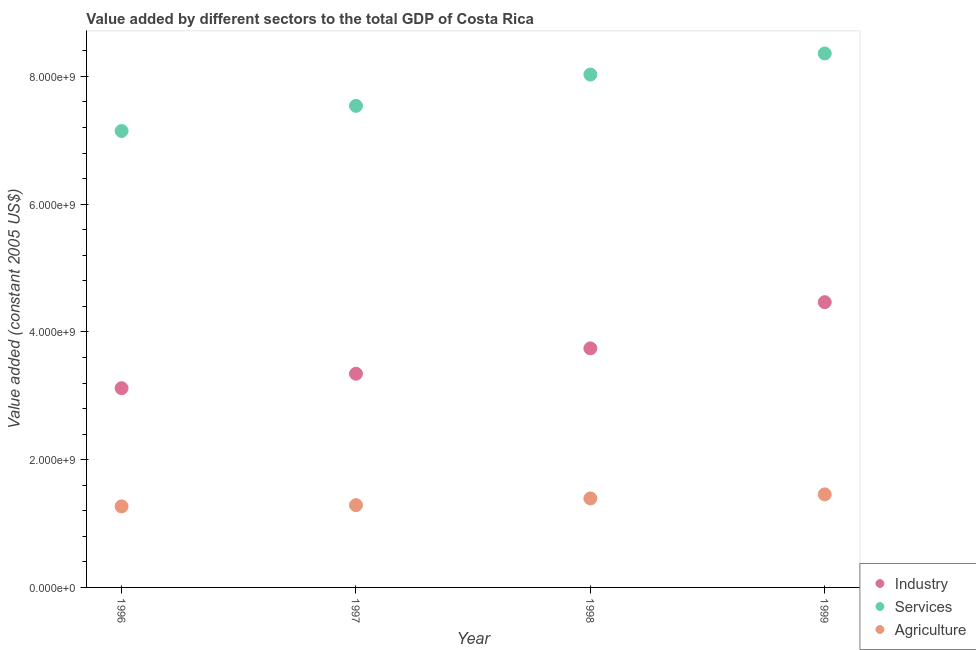Is the number of dotlines equal to the number of legend labels?
Your answer should be compact. Yes. What is the value added by industrial sector in 1997?
Your response must be concise. 3.35e+09. Across all years, what is the maximum value added by industrial sector?
Give a very brief answer. 4.47e+09. Across all years, what is the minimum value added by industrial sector?
Give a very brief answer. 3.12e+09. What is the total value added by agricultural sector in the graph?
Your answer should be very brief. 5.41e+09. What is the difference between the value added by agricultural sector in 1997 and that in 1999?
Offer a terse response. -1.69e+08. What is the difference between the value added by services in 1999 and the value added by agricultural sector in 1996?
Ensure brevity in your answer.  7.09e+09. What is the average value added by industrial sector per year?
Make the answer very short. 3.67e+09. In the year 1998, what is the difference between the value added by agricultural sector and value added by services?
Keep it short and to the point. -6.64e+09. In how many years, is the value added by agricultural sector greater than 6800000000 US$?
Give a very brief answer. 0. What is the ratio of the value added by agricultural sector in 1998 to that in 1999?
Provide a short and direct response. 0.96. Is the value added by industrial sector in 1997 less than that in 1999?
Offer a terse response. Yes. Is the difference between the value added by industrial sector in 1997 and 1999 greater than the difference between the value added by services in 1997 and 1999?
Keep it short and to the point. No. What is the difference between the highest and the second highest value added by services?
Provide a short and direct response. 3.30e+08. What is the difference between the highest and the lowest value added by industrial sector?
Give a very brief answer. 1.35e+09. In how many years, is the value added by industrial sector greater than the average value added by industrial sector taken over all years?
Your response must be concise. 2. Is it the case that in every year, the sum of the value added by industrial sector and value added by services is greater than the value added by agricultural sector?
Give a very brief answer. Yes. Is the value added by agricultural sector strictly greater than the value added by industrial sector over the years?
Keep it short and to the point. No. Is the value added by agricultural sector strictly less than the value added by industrial sector over the years?
Your response must be concise. Yes. How many dotlines are there?
Your answer should be very brief. 3. How many years are there in the graph?
Keep it short and to the point. 4. How many legend labels are there?
Keep it short and to the point. 3. How are the legend labels stacked?
Make the answer very short. Vertical. What is the title of the graph?
Your answer should be very brief. Value added by different sectors to the total GDP of Costa Rica. What is the label or title of the X-axis?
Your response must be concise. Year. What is the label or title of the Y-axis?
Give a very brief answer. Value added (constant 2005 US$). What is the Value added (constant 2005 US$) of Industry in 1996?
Make the answer very short. 3.12e+09. What is the Value added (constant 2005 US$) of Services in 1996?
Keep it short and to the point. 7.15e+09. What is the Value added (constant 2005 US$) in Agriculture in 1996?
Your response must be concise. 1.27e+09. What is the Value added (constant 2005 US$) in Industry in 1997?
Ensure brevity in your answer.  3.35e+09. What is the Value added (constant 2005 US$) of Services in 1997?
Provide a short and direct response. 7.54e+09. What is the Value added (constant 2005 US$) in Agriculture in 1997?
Your response must be concise. 1.29e+09. What is the Value added (constant 2005 US$) of Industry in 1998?
Ensure brevity in your answer.  3.74e+09. What is the Value added (constant 2005 US$) in Services in 1998?
Offer a very short reply. 8.03e+09. What is the Value added (constant 2005 US$) of Agriculture in 1998?
Provide a succinct answer. 1.39e+09. What is the Value added (constant 2005 US$) in Industry in 1999?
Your answer should be compact. 4.47e+09. What is the Value added (constant 2005 US$) of Services in 1999?
Ensure brevity in your answer.  8.36e+09. What is the Value added (constant 2005 US$) of Agriculture in 1999?
Make the answer very short. 1.46e+09. Across all years, what is the maximum Value added (constant 2005 US$) in Industry?
Make the answer very short. 4.47e+09. Across all years, what is the maximum Value added (constant 2005 US$) of Services?
Ensure brevity in your answer.  8.36e+09. Across all years, what is the maximum Value added (constant 2005 US$) in Agriculture?
Make the answer very short. 1.46e+09. Across all years, what is the minimum Value added (constant 2005 US$) in Industry?
Your answer should be very brief. 3.12e+09. Across all years, what is the minimum Value added (constant 2005 US$) of Services?
Your response must be concise. 7.15e+09. Across all years, what is the minimum Value added (constant 2005 US$) in Agriculture?
Give a very brief answer. 1.27e+09. What is the total Value added (constant 2005 US$) of Industry in the graph?
Your answer should be compact. 1.47e+1. What is the total Value added (constant 2005 US$) in Services in the graph?
Offer a very short reply. 3.11e+1. What is the total Value added (constant 2005 US$) in Agriculture in the graph?
Make the answer very short. 5.41e+09. What is the difference between the Value added (constant 2005 US$) of Industry in 1996 and that in 1997?
Offer a very short reply. -2.27e+08. What is the difference between the Value added (constant 2005 US$) in Services in 1996 and that in 1997?
Give a very brief answer. -3.93e+08. What is the difference between the Value added (constant 2005 US$) in Agriculture in 1996 and that in 1997?
Make the answer very short. -1.88e+07. What is the difference between the Value added (constant 2005 US$) of Industry in 1996 and that in 1998?
Provide a short and direct response. -6.24e+08. What is the difference between the Value added (constant 2005 US$) of Services in 1996 and that in 1998?
Your answer should be compact. -8.84e+08. What is the difference between the Value added (constant 2005 US$) of Agriculture in 1996 and that in 1998?
Your answer should be very brief. -1.24e+08. What is the difference between the Value added (constant 2005 US$) in Industry in 1996 and that in 1999?
Give a very brief answer. -1.35e+09. What is the difference between the Value added (constant 2005 US$) of Services in 1996 and that in 1999?
Offer a very short reply. -1.21e+09. What is the difference between the Value added (constant 2005 US$) in Agriculture in 1996 and that in 1999?
Provide a succinct answer. -1.88e+08. What is the difference between the Value added (constant 2005 US$) of Industry in 1997 and that in 1998?
Your response must be concise. -3.97e+08. What is the difference between the Value added (constant 2005 US$) of Services in 1997 and that in 1998?
Offer a terse response. -4.90e+08. What is the difference between the Value added (constant 2005 US$) of Agriculture in 1997 and that in 1998?
Your response must be concise. -1.06e+08. What is the difference between the Value added (constant 2005 US$) of Industry in 1997 and that in 1999?
Provide a succinct answer. -1.12e+09. What is the difference between the Value added (constant 2005 US$) in Services in 1997 and that in 1999?
Provide a short and direct response. -8.20e+08. What is the difference between the Value added (constant 2005 US$) in Agriculture in 1997 and that in 1999?
Provide a succinct answer. -1.69e+08. What is the difference between the Value added (constant 2005 US$) of Industry in 1998 and that in 1999?
Your response must be concise. -7.23e+08. What is the difference between the Value added (constant 2005 US$) of Services in 1998 and that in 1999?
Provide a succinct answer. -3.30e+08. What is the difference between the Value added (constant 2005 US$) of Agriculture in 1998 and that in 1999?
Offer a very short reply. -6.31e+07. What is the difference between the Value added (constant 2005 US$) in Industry in 1996 and the Value added (constant 2005 US$) in Services in 1997?
Keep it short and to the point. -4.42e+09. What is the difference between the Value added (constant 2005 US$) of Industry in 1996 and the Value added (constant 2005 US$) of Agriculture in 1997?
Keep it short and to the point. 1.83e+09. What is the difference between the Value added (constant 2005 US$) of Services in 1996 and the Value added (constant 2005 US$) of Agriculture in 1997?
Your answer should be compact. 5.86e+09. What is the difference between the Value added (constant 2005 US$) in Industry in 1996 and the Value added (constant 2005 US$) in Services in 1998?
Offer a very short reply. -4.91e+09. What is the difference between the Value added (constant 2005 US$) of Industry in 1996 and the Value added (constant 2005 US$) of Agriculture in 1998?
Give a very brief answer. 1.73e+09. What is the difference between the Value added (constant 2005 US$) in Services in 1996 and the Value added (constant 2005 US$) in Agriculture in 1998?
Your answer should be very brief. 5.75e+09. What is the difference between the Value added (constant 2005 US$) in Industry in 1996 and the Value added (constant 2005 US$) in Services in 1999?
Provide a short and direct response. -5.24e+09. What is the difference between the Value added (constant 2005 US$) in Industry in 1996 and the Value added (constant 2005 US$) in Agriculture in 1999?
Give a very brief answer. 1.66e+09. What is the difference between the Value added (constant 2005 US$) of Services in 1996 and the Value added (constant 2005 US$) of Agriculture in 1999?
Offer a terse response. 5.69e+09. What is the difference between the Value added (constant 2005 US$) in Industry in 1997 and the Value added (constant 2005 US$) in Services in 1998?
Your answer should be compact. -4.68e+09. What is the difference between the Value added (constant 2005 US$) in Industry in 1997 and the Value added (constant 2005 US$) in Agriculture in 1998?
Ensure brevity in your answer.  1.95e+09. What is the difference between the Value added (constant 2005 US$) of Services in 1997 and the Value added (constant 2005 US$) of Agriculture in 1998?
Provide a succinct answer. 6.15e+09. What is the difference between the Value added (constant 2005 US$) of Industry in 1997 and the Value added (constant 2005 US$) of Services in 1999?
Offer a terse response. -5.01e+09. What is the difference between the Value added (constant 2005 US$) in Industry in 1997 and the Value added (constant 2005 US$) in Agriculture in 1999?
Give a very brief answer. 1.89e+09. What is the difference between the Value added (constant 2005 US$) of Services in 1997 and the Value added (constant 2005 US$) of Agriculture in 1999?
Keep it short and to the point. 6.08e+09. What is the difference between the Value added (constant 2005 US$) of Industry in 1998 and the Value added (constant 2005 US$) of Services in 1999?
Provide a short and direct response. -4.62e+09. What is the difference between the Value added (constant 2005 US$) of Industry in 1998 and the Value added (constant 2005 US$) of Agriculture in 1999?
Make the answer very short. 2.29e+09. What is the difference between the Value added (constant 2005 US$) in Services in 1998 and the Value added (constant 2005 US$) in Agriculture in 1999?
Your answer should be very brief. 6.57e+09. What is the average Value added (constant 2005 US$) of Industry per year?
Keep it short and to the point. 3.67e+09. What is the average Value added (constant 2005 US$) of Services per year?
Your response must be concise. 7.77e+09. What is the average Value added (constant 2005 US$) of Agriculture per year?
Your answer should be compact. 1.35e+09. In the year 1996, what is the difference between the Value added (constant 2005 US$) of Industry and Value added (constant 2005 US$) of Services?
Offer a very short reply. -4.03e+09. In the year 1996, what is the difference between the Value added (constant 2005 US$) in Industry and Value added (constant 2005 US$) in Agriculture?
Provide a succinct answer. 1.85e+09. In the year 1996, what is the difference between the Value added (constant 2005 US$) of Services and Value added (constant 2005 US$) of Agriculture?
Your answer should be very brief. 5.88e+09. In the year 1997, what is the difference between the Value added (constant 2005 US$) in Industry and Value added (constant 2005 US$) in Services?
Offer a very short reply. -4.19e+09. In the year 1997, what is the difference between the Value added (constant 2005 US$) in Industry and Value added (constant 2005 US$) in Agriculture?
Your answer should be compact. 2.06e+09. In the year 1997, what is the difference between the Value added (constant 2005 US$) in Services and Value added (constant 2005 US$) in Agriculture?
Give a very brief answer. 6.25e+09. In the year 1998, what is the difference between the Value added (constant 2005 US$) of Industry and Value added (constant 2005 US$) of Services?
Make the answer very short. -4.29e+09. In the year 1998, what is the difference between the Value added (constant 2005 US$) of Industry and Value added (constant 2005 US$) of Agriculture?
Provide a succinct answer. 2.35e+09. In the year 1998, what is the difference between the Value added (constant 2005 US$) in Services and Value added (constant 2005 US$) in Agriculture?
Your response must be concise. 6.64e+09. In the year 1999, what is the difference between the Value added (constant 2005 US$) of Industry and Value added (constant 2005 US$) of Services?
Your answer should be compact. -3.89e+09. In the year 1999, what is the difference between the Value added (constant 2005 US$) of Industry and Value added (constant 2005 US$) of Agriculture?
Provide a short and direct response. 3.01e+09. In the year 1999, what is the difference between the Value added (constant 2005 US$) in Services and Value added (constant 2005 US$) in Agriculture?
Give a very brief answer. 6.90e+09. What is the ratio of the Value added (constant 2005 US$) of Industry in 1996 to that in 1997?
Provide a short and direct response. 0.93. What is the ratio of the Value added (constant 2005 US$) in Services in 1996 to that in 1997?
Your response must be concise. 0.95. What is the ratio of the Value added (constant 2005 US$) of Agriculture in 1996 to that in 1997?
Your answer should be very brief. 0.99. What is the ratio of the Value added (constant 2005 US$) in Industry in 1996 to that in 1998?
Provide a succinct answer. 0.83. What is the ratio of the Value added (constant 2005 US$) in Services in 1996 to that in 1998?
Provide a succinct answer. 0.89. What is the ratio of the Value added (constant 2005 US$) in Agriculture in 1996 to that in 1998?
Keep it short and to the point. 0.91. What is the ratio of the Value added (constant 2005 US$) in Industry in 1996 to that in 1999?
Keep it short and to the point. 0.7. What is the ratio of the Value added (constant 2005 US$) of Services in 1996 to that in 1999?
Give a very brief answer. 0.85. What is the ratio of the Value added (constant 2005 US$) in Agriculture in 1996 to that in 1999?
Offer a terse response. 0.87. What is the ratio of the Value added (constant 2005 US$) in Industry in 1997 to that in 1998?
Your response must be concise. 0.89. What is the ratio of the Value added (constant 2005 US$) of Services in 1997 to that in 1998?
Offer a terse response. 0.94. What is the ratio of the Value added (constant 2005 US$) in Agriculture in 1997 to that in 1998?
Your answer should be very brief. 0.92. What is the ratio of the Value added (constant 2005 US$) in Industry in 1997 to that in 1999?
Offer a terse response. 0.75. What is the ratio of the Value added (constant 2005 US$) of Services in 1997 to that in 1999?
Your answer should be very brief. 0.9. What is the ratio of the Value added (constant 2005 US$) of Agriculture in 1997 to that in 1999?
Ensure brevity in your answer.  0.88. What is the ratio of the Value added (constant 2005 US$) of Industry in 1998 to that in 1999?
Your answer should be compact. 0.84. What is the ratio of the Value added (constant 2005 US$) of Services in 1998 to that in 1999?
Keep it short and to the point. 0.96. What is the ratio of the Value added (constant 2005 US$) in Agriculture in 1998 to that in 1999?
Ensure brevity in your answer.  0.96. What is the difference between the highest and the second highest Value added (constant 2005 US$) of Industry?
Give a very brief answer. 7.23e+08. What is the difference between the highest and the second highest Value added (constant 2005 US$) of Services?
Offer a terse response. 3.30e+08. What is the difference between the highest and the second highest Value added (constant 2005 US$) of Agriculture?
Give a very brief answer. 6.31e+07. What is the difference between the highest and the lowest Value added (constant 2005 US$) in Industry?
Offer a very short reply. 1.35e+09. What is the difference between the highest and the lowest Value added (constant 2005 US$) in Services?
Ensure brevity in your answer.  1.21e+09. What is the difference between the highest and the lowest Value added (constant 2005 US$) of Agriculture?
Your response must be concise. 1.88e+08. 